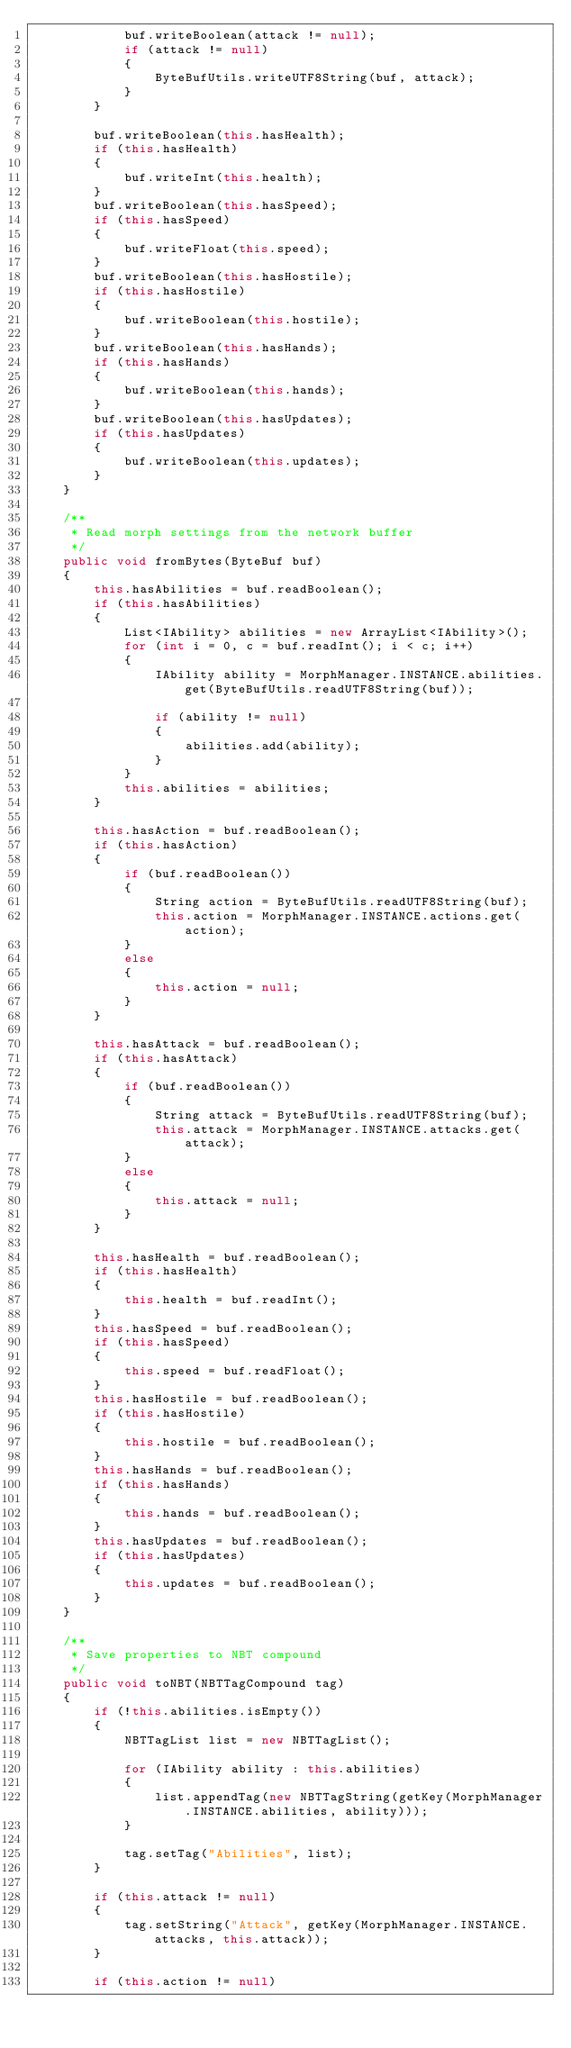Convert code to text. <code><loc_0><loc_0><loc_500><loc_500><_Java_>            buf.writeBoolean(attack != null);
            if (attack != null)
            {
                ByteBufUtils.writeUTF8String(buf, attack);
            }
        }
        
        buf.writeBoolean(this.hasHealth);
        if (this.hasHealth)
        {
            buf.writeInt(this.health);
        }
        buf.writeBoolean(this.hasSpeed);
        if (this.hasSpeed)
        {
            buf.writeFloat(this.speed);
        }
        buf.writeBoolean(this.hasHostile);
        if (this.hasHostile)
        {
            buf.writeBoolean(this.hostile);
        }
        buf.writeBoolean(this.hasHands);
        if (this.hasHands)
        {
            buf.writeBoolean(this.hands);
        }
        buf.writeBoolean(this.hasUpdates);
        if (this.hasUpdates)
        {
            buf.writeBoolean(this.updates);
        }
    }

    /**
     * Read morph settings from the network buffer 
     */
    public void fromBytes(ByteBuf buf)
    {
        this.hasAbilities = buf.readBoolean();
        if (this.hasAbilities)
        {
            List<IAbility> abilities = new ArrayList<IAbility>();
            for (int i = 0, c = buf.readInt(); i < c; i++)
            {
                IAbility ability = MorphManager.INSTANCE.abilities.get(ByteBufUtils.readUTF8String(buf));
    
                if (ability != null)
                {
                    abilities.add(ability);
                }
            }
            this.abilities = abilities;
        }

        this.hasAction = buf.readBoolean();
        if (this.hasAction)
        {
            if (buf.readBoolean())
            {
                String action = ByteBufUtils.readUTF8String(buf);
                this.action = MorphManager.INSTANCE.actions.get(action);
            }
            else
            {
                this.action = null;
            }
        }

        this.hasAttack = buf.readBoolean();
        if (this.hasAttack)
        {
            if (buf.readBoolean())
            {
                String attack = ByteBufUtils.readUTF8String(buf);
                this.attack = MorphManager.INSTANCE.attacks.get(attack);
            }
            else
            {
                this.attack = null;
            }
        }

        this.hasHealth = buf.readBoolean();
        if (this.hasHealth)
        {
            this.health = buf.readInt();
        }
        this.hasSpeed = buf.readBoolean();
        if (this.hasSpeed)
        {
            this.speed = buf.readFloat();
        }
        this.hasHostile = buf.readBoolean();
        if (this.hasHostile)
        {
            this.hostile = buf.readBoolean();
        }
        this.hasHands = buf.readBoolean();
        if (this.hasHands)
        {
            this.hands = buf.readBoolean();
        }
        this.hasUpdates = buf.readBoolean();
        if (this.hasUpdates)
        {
            this.updates = buf.readBoolean();
        }
    }

    /**
     * Save properties to NBT compound
     */
    public void toNBT(NBTTagCompound tag)
    {
        if (!this.abilities.isEmpty())
        {
            NBTTagList list = new NBTTagList();

            for (IAbility ability : this.abilities)
            {
                list.appendTag(new NBTTagString(getKey(MorphManager.INSTANCE.abilities, ability)));
            }

            tag.setTag("Abilities", list);
        }

        if (this.attack != null)
        {
            tag.setString("Attack", getKey(MorphManager.INSTANCE.attacks, this.attack));
        }

        if (this.action != null)</code> 